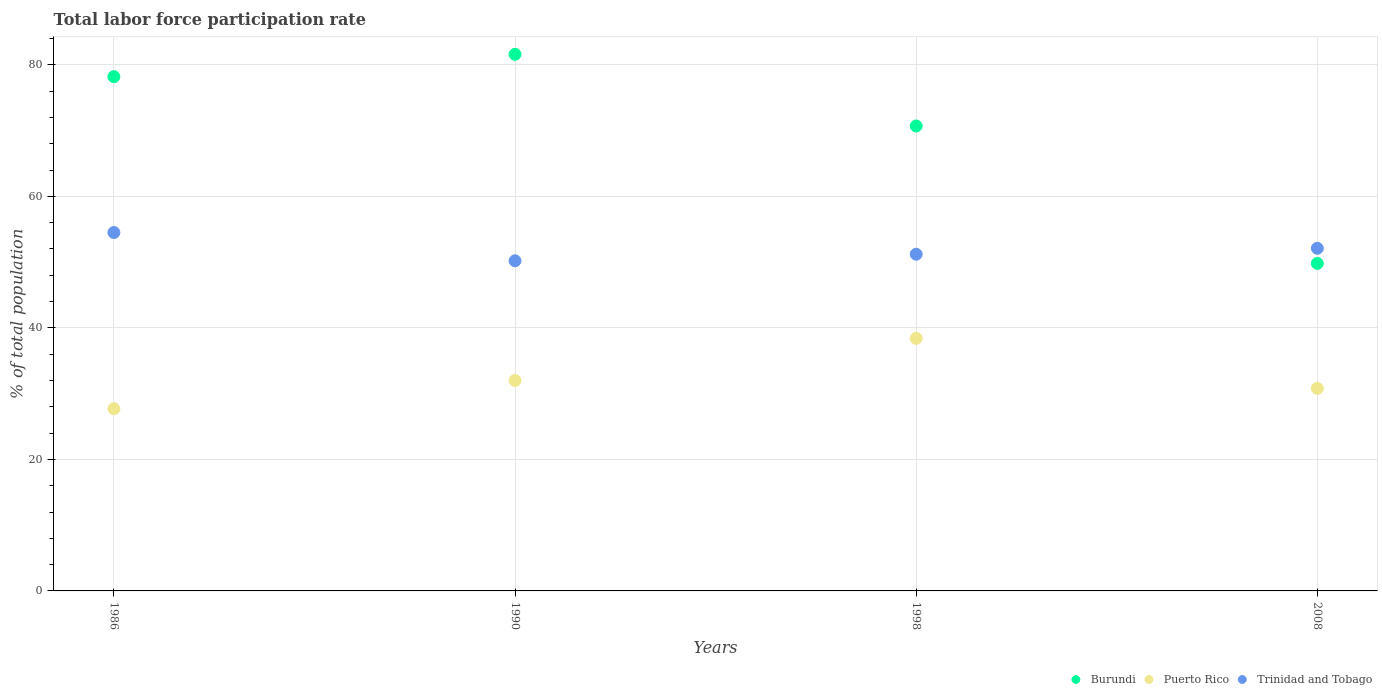What is the total labor force participation rate in Burundi in 1990?
Provide a short and direct response. 81.6. Across all years, what is the maximum total labor force participation rate in Trinidad and Tobago?
Your answer should be very brief. 54.5. Across all years, what is the minimum total labor force participation rate in Trinidad and Tobago?
Ensure brevity in your answer.  50.2. In which year was the total labor force participation rate in Trinidad and Tobago maximum?
Make the answer very short. 1986. What is the total total labor force participation rate in Burundi in the graph?
Your answer should be very brief. 280.3. What is the difference between the total labor force participation rate in Puerto Rico in 1990 and that in 2008?
Your answer should be compact. 1.2. What is the difference between the total labor force participation rate in Burundi in 1998 and the total labor force participation rate in Puerto Rico in 2008?
Keep it short and to the point. 39.9. What is the average total labor force participation rate in Burundi per year?
Offer a terse response. 70.07. In the year 1986, what is the difference between the total labor force participation rate in Puerto Rico and total labor force participation rate in Burundi?
Give a very brief answer. -50.5. What is the ratio of the total labor force participation rate in Burundi in 1986 to that in 1990?
Your answer should be compact. 0.96. Is the total labor force participation rate in Puerto Rico in 1990 less than that in 1998?
Provide a short and direct response. Yes. Is the difference between the total labor force participation rate in Puerto Rico in 1990 and 2008 greater than the difference between the total labor force participation rate in Burundi in 1990 and 2008?
Your answer should be compact. No. What is the difference between the highest and the second highest total labor force participation rate in Trinidad and Tobago?
Your answer should be very brief. 2.4. What is the difference between the highest and the lowest total labor force participation rate in Trinidad and Tobago?
Give a very brief answer. 4.3. In how many years, is the total labor force participation rate in Puerto Rico greater than the average total labor force participation rate in Puerto Rico taken over all years?
Your answer should be compact. 1. Does the total labor force participation rate in Puerto Rico monotonically increase over the years?
Ensure brevity in your answer.  No. Is the total labor force participation rate in Puerto Rico strictly greater than the total labor force participation rate in Trinidad and Tobago over the years?
Your response must be concise. No. How many years are there in the graph?
Your answer should be compact. 4. What is the difference between two consecutive major ticks on the Y-axis?
Offer a terse response. 20. Does the graph contain any zero values?
Make the answer very short. No. Where does the legend appear in the graph?
Offer a terse response. Bottom right. How are the legend labels stacked?
Give a very brief answer. Horizontal. What is the title of the graph?
Offer a very short reply. Total labor force participation rate. Does "High income" appear as one of the legend labels in the graph?
Offer a terse response. No. What is the label or title of the X-axis?
Your response must be concise. Years. What is the label or title of the Y-axis?
Offer a very short reply. % of total population. What is the % of total population in Burundi in 1986?
Your response must be concise. 78.2. What is the % of total population of Puerto Rico in 1986?
Offer a terse response. 27.7. What is the % of total population in Trinidad and Tobago in 1986?
Your answer should be very brief. 54.5. What is the % of total population in Burundi in 1990?
Ensure brevity in your answer.  81.6. What is the % of total population in Puerto Rico in 1990?
Keep it short and to the point. 32. What is the % of total population in Trinidad and Tobago in 1990?
Ensure brevity in your answer.  50.2. What is the % of total population in Burundi in 1998?
Offer a very short reply. 70.7. What is the % of total population of Puerto Rico in 1998?
Offer a very short reply. 38.4. What is the % of total population in Trinidad and Tobago in 1998?
Offer a terse response. 51.2. What is the % of total population of Burundi in 2008?
Provide a short and direct response. 49.8. What is the % of total population of Puerto Rico in 2008?
Your answer should be very brief. 30.8. What is the % of total population of Trinidad and Tobago in 2008?
Keep it short and to the point. 52.1. Across all years, what is the maximum % of total population of Burundi?
Provide a succinct answer. 81.6. Across all years, what is the maximum % of total population of Puerto Rico?
Ensure brevity in your answer.  38.4. Across all years, what is the maximum % of total population of Trinidad and Tobago?
Offer a terse response. 54.5. Across all years, what is the minimum % of total population in Burundi?
Your answer should be compact. 49.8. Across all years, what is the minimum % of total population in Puerto Rico?
Your response must be concise. 27.7. Across all years, what is the minimum % of total population of Trinidad and Tobago?
Give a very brief answer. 50.2. What is the total % of total population in Burundi in the graph?
Keep it short and to the point. 280.3. What is the total % of total population in Puerto Rico in the graph?
Your answer should be compact. 128.9. What is the total % of total population of Trinidad and Tobago in the graph?
Offer a terse response. 208. What is the difference between the % of total population of Burundi in 1986 and that in 1990?
Ensure brevity in your answer.  -3.4. What is the difference between the % of total population in Trinidad and Tobago in 1986 and that in 1990?
Your response must be concise. 4.3. What is the difference between the % of total population of Puerto Rico in 1986 and that in 1998?
Provide a succinct answer. -10.7. What is the difference between the % of total population of Trinidad and Tobago in 1986 and that in 1998?
Ensure brevity in your answer.  3.3. What is the difference between the % of total population in Burundi in 1986 and that in 2008?
Your answer should be compact. 28.4. What is the difference between the % of total population of Puerto Rico in 1986 and that in 2008?
Your answer should be very brief. -3.1. What is the difference between the % of total population in Trinidad and Tobago in 1986 and that in 2008?
Make the answer very short. 2.4. What is the difference between the % of total population in Burundi in 1990 and that in 1998?
Offer a terse response. 10.9. What is the difference between the % of total population of Puerto Rico in 1990 and that in 1998?
Offer a terse response. -6.4. What is the difference between the % of total population of Burundi in 1990 and that in 2008?
Keep it short and to the point. 31.8. What is the difference between the % of total population in Burundi in 1998 and that in 2008?
Give a very brief answer. 20.9. What is the difference between the % of total population of Trinidad and Tobago in 1998 and that in 2008?
Offer a terse response. -0.9. What is the difference between the % of total population in Burundi in 1986 and the % of total population in Puerto Rico in 1990?
Offer a terse response. 46.2. What is the difference between the % of total population of Burundi in 1986 and the % of total population of Trinidad and Tobago in 1990?
Your answer should be compact. 28. What is the difference between the % of total population in Puerto Rico in 1986 and the % of total population in Trinidad and Tobago in 1990?
Your answer should be very brief. -22.5. What is the difference between the % of total population of Burundi in 1986 and the % of total population of Puerto Rico in 1998?
Offer a terse response. 39.8. What is the difference between the % of total population in Burundi in 1986 and the % of total population in Trinidad and Tobago in 1998?
Offer a very short reply. 27. What is the difference between the % of total population in Puerto Rico in 1986 and the % of total population in Trinidad and Tobago in 1998?
Offer a terse response. -23.5. What is the difference between the % of total population of Burundi in 1986 and the % of total population of Puerto Rico in 2008?
Provide a succinct answer. 47.4. What is the difference between the % of total population of Burundi in 1986 and the % of total population of Trinidad and Tobago in 2008?
Make the answer very short. 26.1. What is the difference between the % of total population of Puerto Rico in 1986 and the % of total population of Trinidad and Tobago in 2008?
Offer a terse response. -24.4. What is the difference between the % of total population of Burundi in 1990 and the % of total population of Puerto Rico in 1998?
Your response must be concise. 43.2. What is the difference between the % of total population of Burundi in 1990 and the % of total population of Trinidad and Tobago in 1998?
Offer a very short reply. 30.4. What is the difference between the % of total population of Puerto Rico in 1990 and the % of total population of Trinidad and Tobago in 1998?
Provide a short and direct response. -19.2. What is the difference between the % of total population of Burundi in 1990 and the % of total population of Puerto Rico in 2008?
Your answer should be very brief. 50.8. What is the difference between the % of total population in Burundi in 1990 and the % of total population in Trinidad and Tobago in 2008?
Offer a very short reply. 29.5. What is the difference between the % of total population of Puerto Rico in 1990 and the % of total population of Trinidad and Tobago in 2008?
Make the answer very short. -20.1. What is the difference between the % of total population in Burundi in 1998 and the % of total population in Puerto Rico in 2008?
Offer a very short reply. 39.9. What is the difference between the % of total population in Puerto Rico in 1998 and the % of total population in Trinidad and Tobago in 2008?
Ensure brevity in your answer.  -13.7. What is the average % of total population of Burundi per year?
Keep it short and to the point. 70.08. What is the average % of total population of Puerto Rico per year?
Offer a very short reply. 32.23. In the year 1986, what is the difference between the % of total population of Burundi and % of total population of Puerto Rico?
Your answer should be very brief. 50.5. In the year 1986, what is the difference between the % of total population in Burundi and % of total population in Trinidad and Tobago?
Keep it short and to the point. 23.7. In the year 1986, what is the difference between the % of total population of Puerto Rico and % of total population of Trinidad and Tobago?
Provide a succinct answer. -26.8. In the year 1990, what is the difference between the % of total population of Burundi and % of total population of Puerto Rico?
Your answer should be compact. 49.6. In the year 1990, what is the difference between the % of total population in Burundi and % of total population in Trinidad and Tobago?
Your response must be concise. 31.4. In the year 1990, what is the difference between the % of total population in Puerto Rico and % of total population in Trinidad and Tobago?
Your answer should be compact. -18.2. In the year 1998, what is the difference between the % of total population in Burundi and % of total population in Puerto Rico?
Provide a short and direct response. 32.3. In the year 1998, what is the difference between the % of total population of Puerto Rico and % of total population of Trinidad and Tobago?
Your answer should be compact. -12.8. In the year 2008, what is the difference between the % of total population of Burundi and % of total population of Puerto Rico?
Offer a terse response. 19. In the year 2008, what is the difference between the % of total population in Burundi and % of total population in Trinidad and Tobago?
Make the answer very short. -2.3. In the year 2008, what is the difference between the % of total population of Puerto Rico and % of total population of Trinidad and Tobago?
Keep it short and to the point. -21.3. What is the ratio of the % of total population in Burundi in 1986 to that in 1990?
Offer a very short reply. 0.96. What is the ratio of the % of total population of Puerto Rico in 1986 to that in 1990?
Provide a short and direct response. 0.87. What is the ratio of the % of total population in Trinidad and Tobago in 1986 to that in 1990?
Provide a short and direct response. 1.09. What is the ratio of the % of total population of Burundi in 1986 to that in 1998?
Offer a very short reply. 1.11. What is the ratio of the % of total population of Puerto Rico in 1986 to that in 1998?
Your response must be concise. 0.72. What is the ratio of the % of total population of Trinidad and Tobago in 1986 to that in 1998?
Your response must be concise. 1.06. What is the ratio of the % of total population of Burundi in 1986 to that in 2008?
Provide a short and direct response. 1.57. What is the ratio of the % of total population in Puerto Rico in 1986 to that in 2008?
Your answer should be compact. 0.9. What is the ratio of the % of total population in Trinidad and Tobago in 1986 to that in 2008?
Ensure brevity in your answer.  1.05. What is the ratio of the % of total population in Burundi in 1990 to that in 1998?
Offer a terse response. 1.15. What is the ratio of the % of total population of Trinidad and Tobago in 1990 to that in 1998?
Give a very brief answer. 0.98. What is the ratio of the % of total population in Burundi in 1990 to that in 2008?
Provide a succinct answer. 1.64. What is the ratio of the % of total population of Puerto Rico in 1990 to that in 2008?
Your answer should be very brief. 1.04. What is the ratio of the % of total population of Trinidad and Tobago in 1990 to that in 2008?
Offer a very short reply. 0.96. What is the ratio of the % of total population in Burundi in 1998 to that in 2008?
Keep it short and to the point. 1.42. What is the ratio of the % of total population in Puerto Rico in 1998 to that in 2008?
Offer a terse response. 1.25. What is the ratio of the % of total population of Trinidad and Tobago in 1998 to that in 2008?
Make the answer very short. 0.98. What is the difference between the highest and the second highest % of total population of Trinidad and Tobago?
Provide a succinct answer. 2.4. What is the difference between the highest and the lowest % of total population of Burundi?
Your response must be concise. 31.8. What is the difference between the highest and the lowest % of total population in Trinidad and Tobago?
Your answer should be compact. 4.3. 